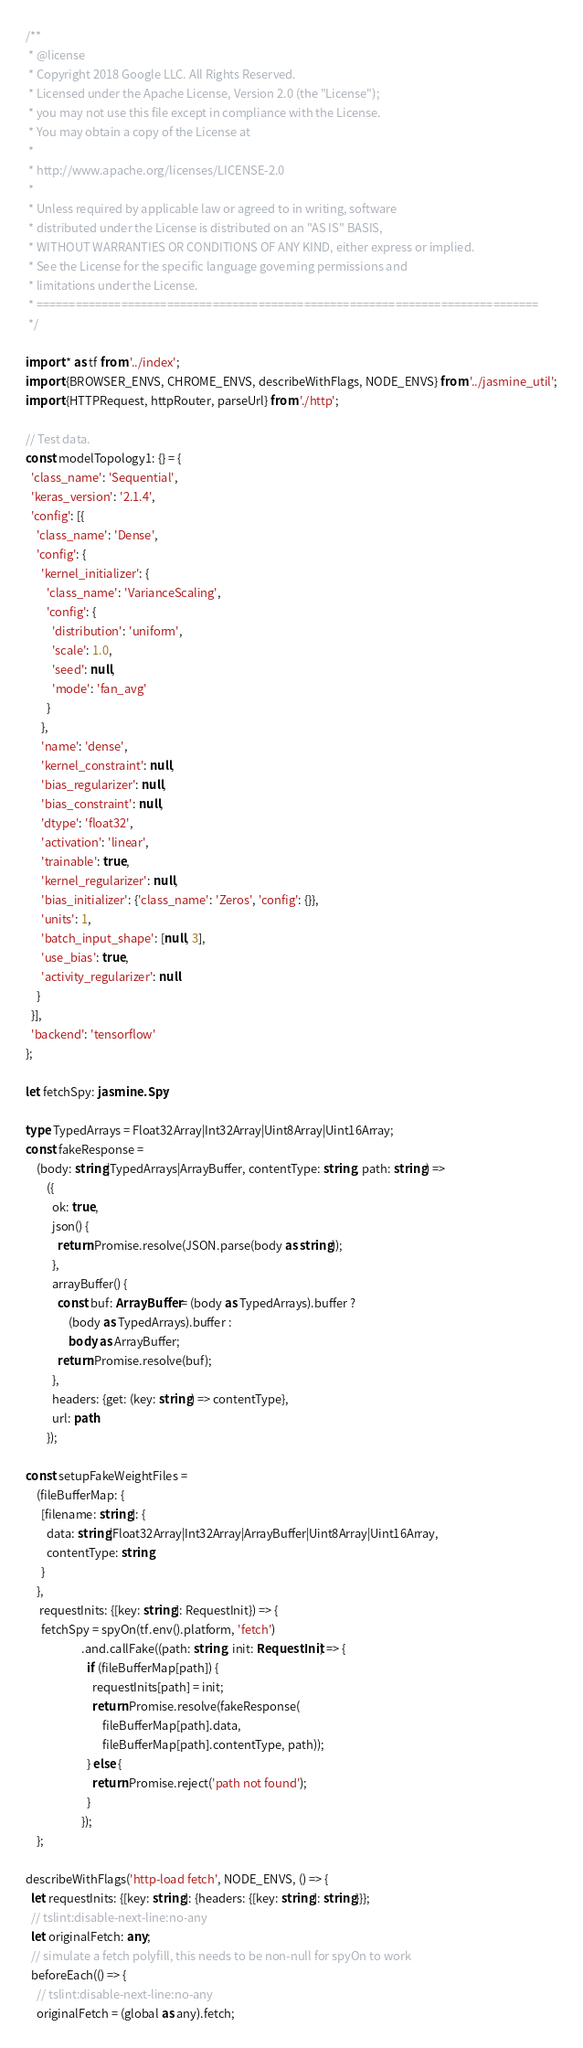Convert code to text. <code><loc_0><loc_0><loc_500><loc_500><_TypeScript_>/**
 * @license
 * Copyright 2018 Google LLC. All Rights Reserved.
 * Licensed under the Apache License, Version 2.0 (the "License");
 * you may not use this file except in compliance with the License.
 * You may obtain a copy of the License at
 *
 * http://www.apache.org/licenses/LICENSE-2.0
 *
 * Unless required by applicable law or agreed to in writing, software
 * distributed under the License is distributed on an "AS IS" BASIS,
 * WITHOUT WARRANTIES OR CONDITIONS OF ANY KIND, either express or implied.
 * See the License for the specific language governing permissions and
 * limitations under the License.
 * =============================================================================
 */

import * as tf from '../index';
import {BROWSER_ENVS, CHROME_ENVS, describeWithFlags, NODE_ENVS} from '../jasmine_util';
import {HTTPRequest, httpRouter, parseUrl} from './http';

// Test data.
const modelTopology1: {} = {
  'class_name': 'Sequential',
  'keras_version': '2.1.4',
  'config': [{
    'class_name': 'Dense',
    'config': {
      'kernel_initializer': {
        'class_name': 'VarianceScaling',
        'config': {
          'distribution': 'uniform',
          'scale': 1.0,
          'seed': null,
          'mode': 'fan_avg'
        }
      },
      'name': 'dense',
      'kernel_constraint': null,
      'bias_regularizer': null,
      'bias_constraint': null,
      'dtype': 'float32',
      'activation': 'linear',
      'trainable': true,
      'kernel_regularizer': null,
      'bias_initializer': {'class_name': 'Zeros', 'config': {}},
      'units': 1,
      'batch_input_shape': [null, 3],
      'use_bias': true,
      'activity_regularizer': null
    }
  }],
  'backend': 'tensorflow'
};

let fetchSpy: jasmine.Spy;

type TypedArrays = Float32Array|Int32Array|Uint8Array|Uint16Array;
const fakeResponse =
    (body: string|TypedArrays|ArrayBuffer, contentType: string, path: string) =>
        ({
          ok: true,
          json() {
            return Promise.resolve(JSON.parse(body as string));
          },
          arrayBuffer() {
            const buf: ArrayBuffer = (body as TypedArrays).buffer ?
                (body as TypedArrays).buffer :
                body as ArrayBuffer;
            return Promise.resolve(buf);
          },
          headers: {get: (key: string) => contentType},
          url: path
        });

const setupFakeWeightFiles =
    (fileBufferMap: {
      [filename: string]: {
        data: string|Float32Array|Int32Array|ArrayBuffer|Uint8Array|Uint16Array,
        contentType: string
      }
    },
     requestInits: {[key: string]: RequestInit}) => {
      fetchSpy = spyOn(tf.env().platform, 'fetch')
                     .and.callFake((path: string, init: RequestInit) => {
                       if (fileBufferMap[path]) {
                         requestInits[path] = init;
                         return Promise.resolve(fakeResponse(
                             fileBufferMap[path].data,
                             fileBufferMap[path].contentType, path));
                       } else {
                         return Promise.reject('path not found');
                       }
                     });
    };

describeWithFlags('http-load fetch', NODE_ENVS, () => {
  let requestInits: {[key: string]: {headers: {[key: string]: string}}};
  // tslint:disable-next-line:no-any
  let originalFetch: any;
  // simulate a fetch polyfill, this needs to be non-null for spyOn to work
  beforeEach(() => {
    // tslint:disable-next-line:no-any
    originalFetch = (global as any).fetch;</code> 